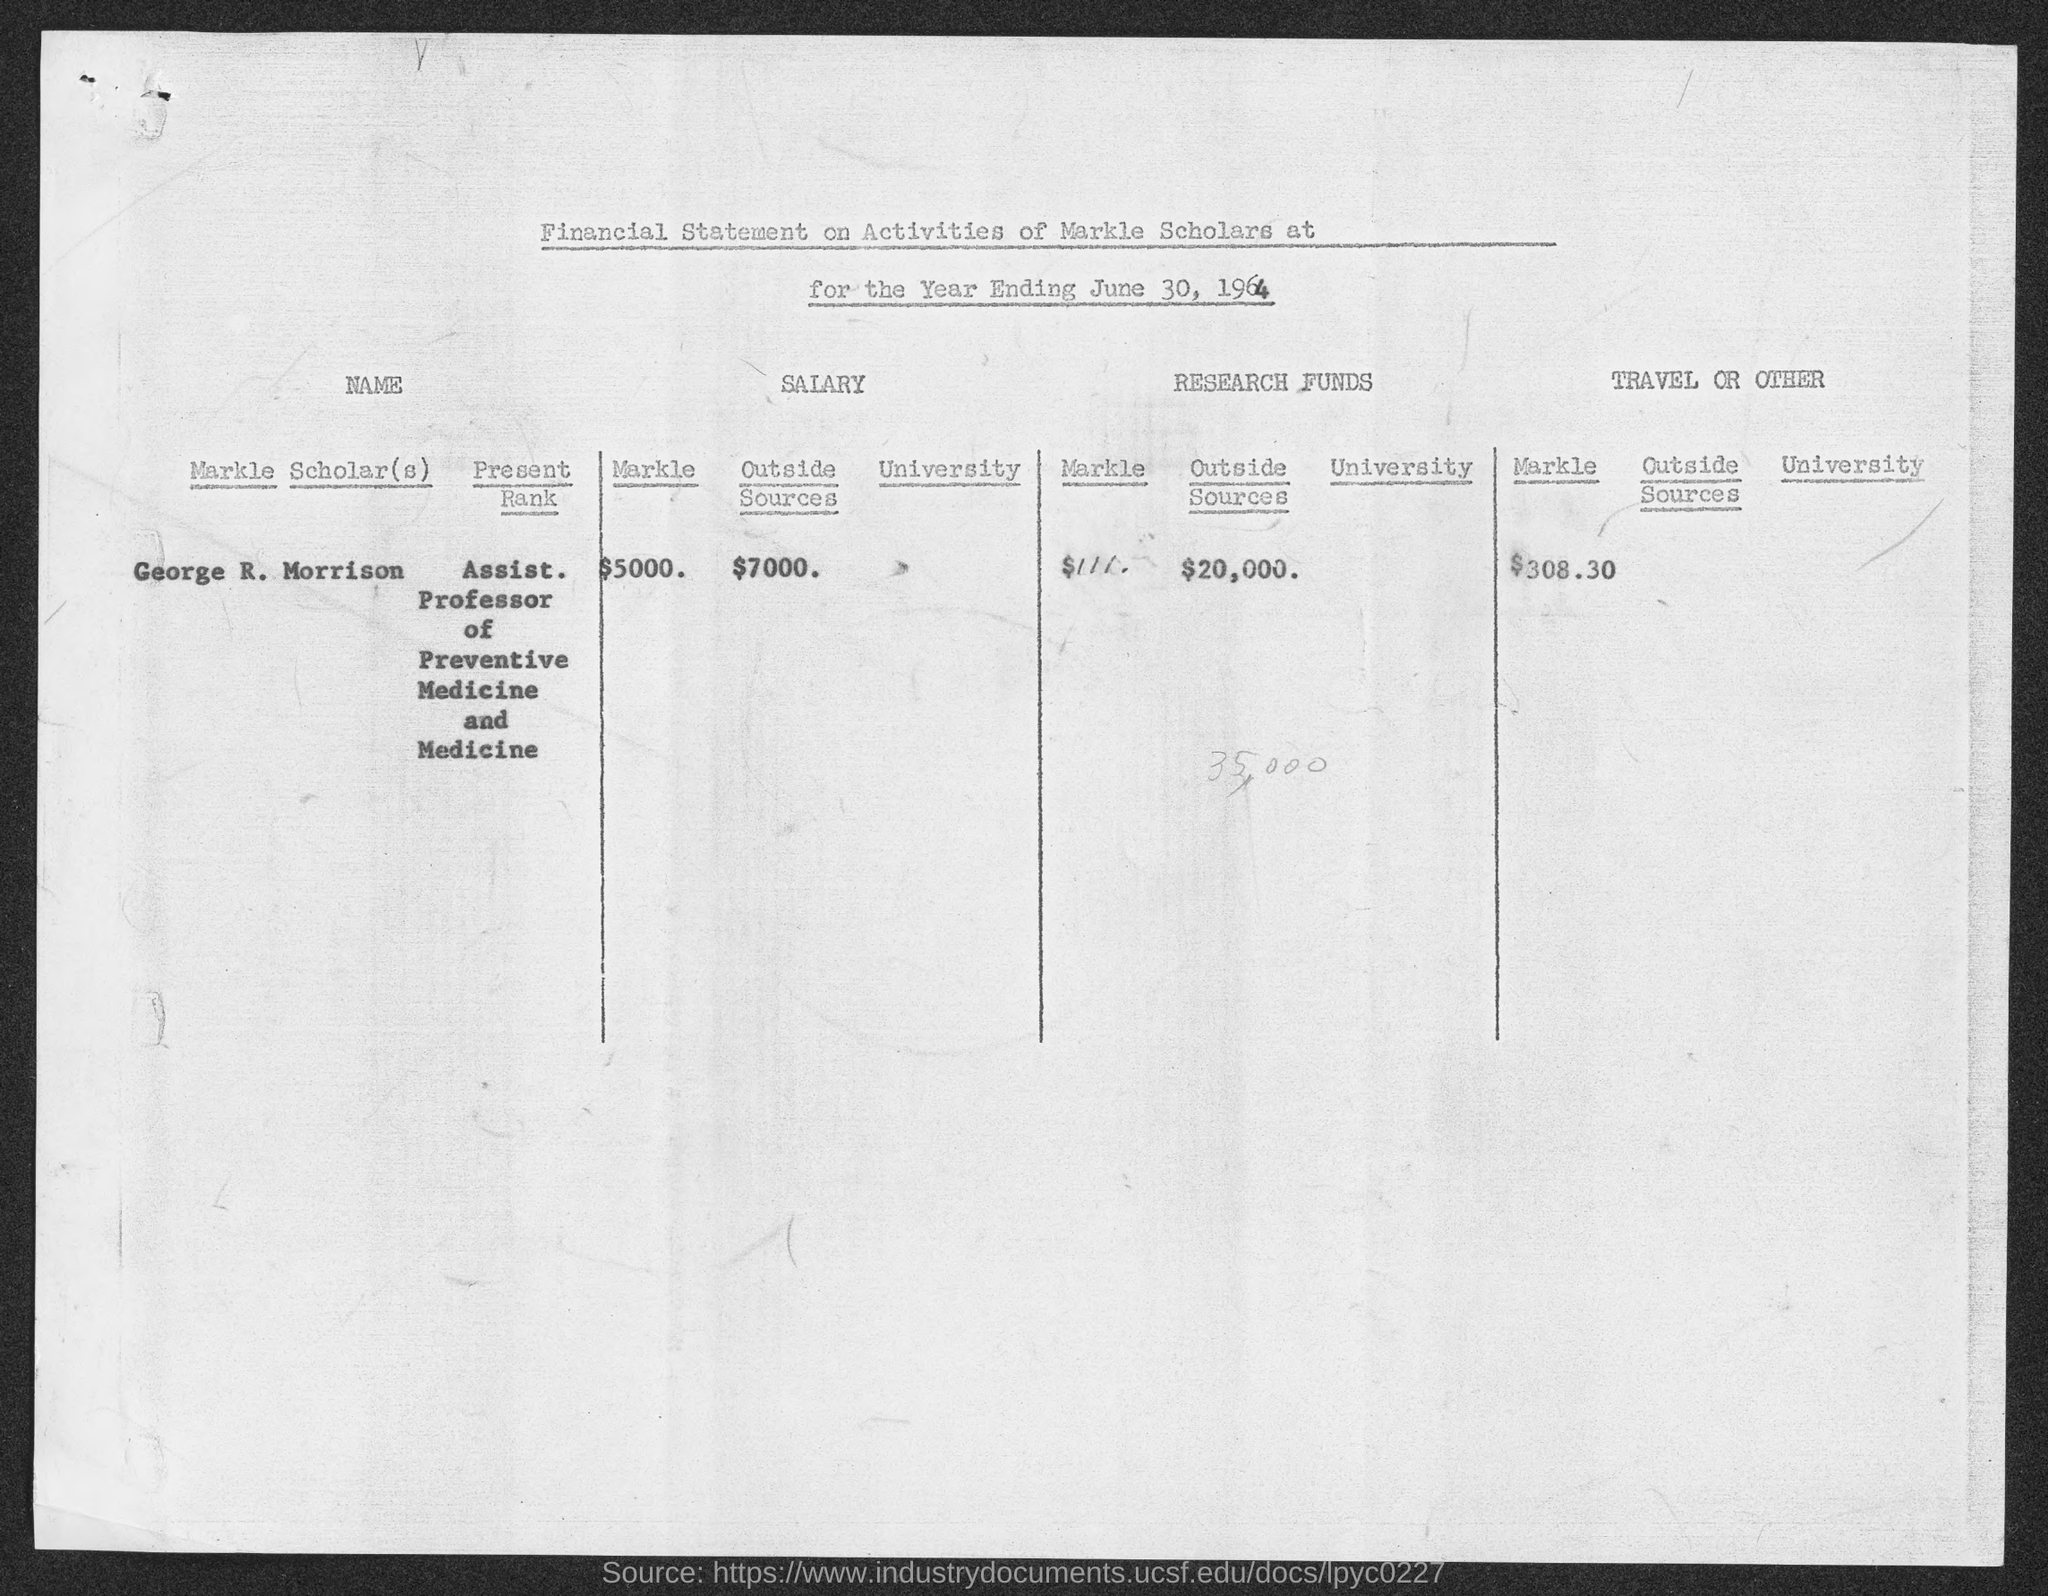List a handful of essential elements in this visual. The amount spent on other expenses is $308.30. I am Assistant Professor of Preventive Medicine and Medicine, known as the Scholar's Rank. Research funds of $20,000 have been allocated for the current fiscal year. The total salary of a Markle Scholar is $5000. The Scholar's name is George R. Morrison. 